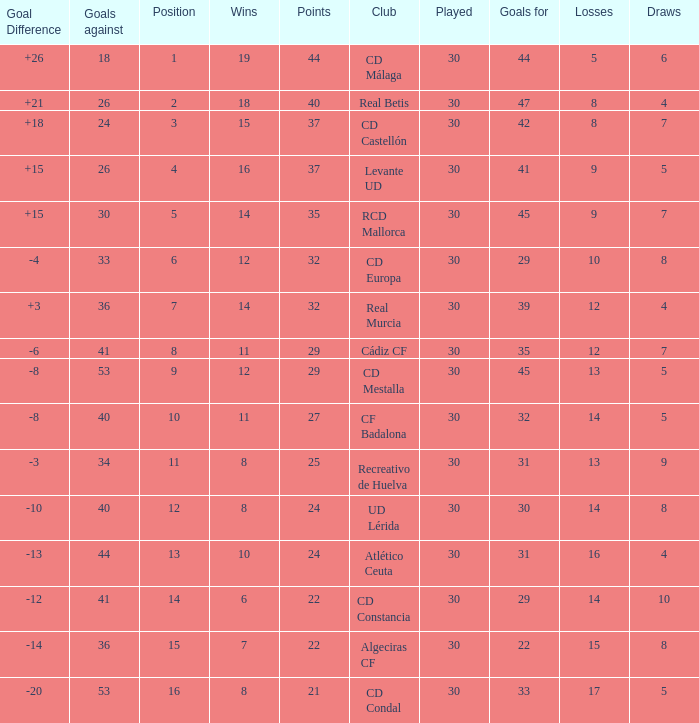What is the losses when the goal difference is larger than 26? None. 